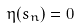<formula> <loc_0><loc_0><loc_500><loc_500>\eta ( s _ { n } ) = 0</formula> 